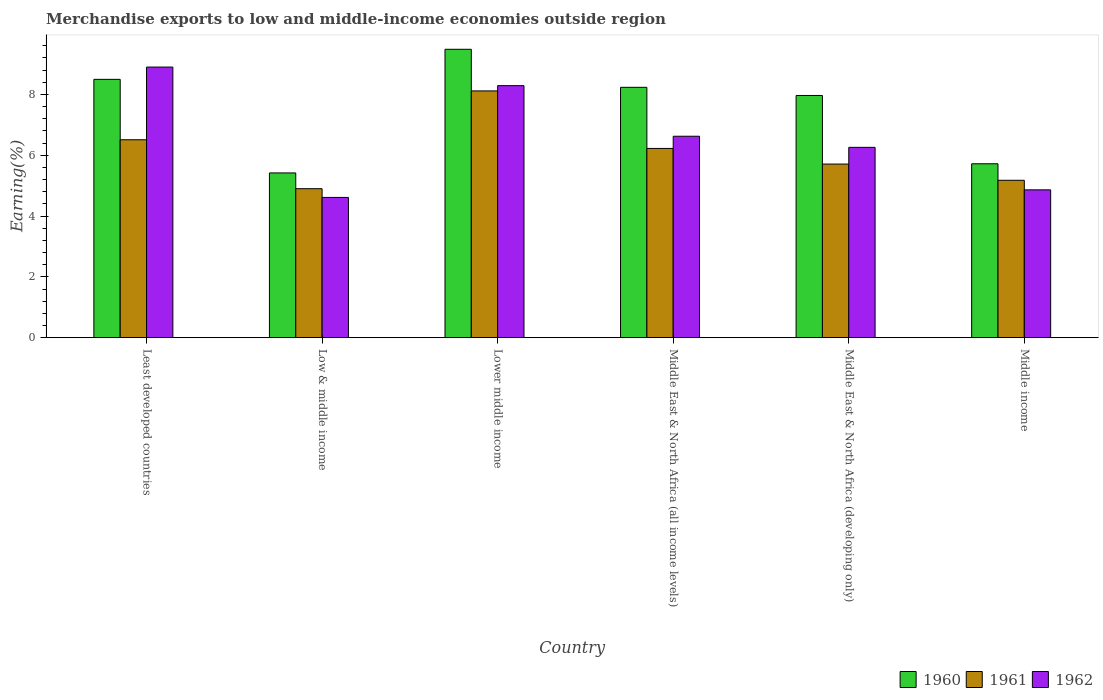What is the label of the 4th group of bars from the left?
Your answer should be very brief. Middle East & North Africa (all income levels). In how many cases, is the number of bars for a given country not equal to the number of legend labels?
Provide a short and direct response. 0. What is the percentage of amount earned from merchandise exports in 1962 in Middle East & North Africa (developing only)?
Provide a short and direct response. 6.26. Across all countries, what is the maximum percentage of amount earned from merchandise exports in 1962?
Keep it short and to the point. 8.9. Across all countries, what is the minimum percentage of amount earned from merchandise exports in 1961?
Your answer should be very brief. 4.9. In which country was the percentage of amount earned from merchandise exports in 1961 maximum?
Make the answer very short. Lower middle income. What is the total percentage of amount earned from merchandise exports in 1962 in the graph?
Give a very brief answer. 39.54. What is the difference between the percentage of amount earned from merchandise exports in 1962 in Middle East & North Africa (all income levels) and that in Middle income?
Your response must be concise. 1.76. What is the difference between the percentage of amount earned from merchandise exports in 1962 in Middle East & North Africa (all income levels) and the percentage of amount earned from merchandise exports in 1960 in Middle East & North Africa (developing only)?
Ensure brevity in your answer.  -1.34. What is the average percentage of amount earned from merchandise exports in 1961 per country?
Give a very brief answer. 6.1. What is the difference between the percentage of amount earned from merchandise exports of/in 1960 and percentage of amount earned from merchandise exports of/in 1962 in Middle income?
Provide a short and direct response. 0.86. What is the ratio of the percentage of amount earned from merchandise exports in 1960 in Least developed countries to that in Low & middle income?
Ensure brevity in your answer.  1.57. Is the difference between the percentage of amount earned from merchandise exports in 1960 in Low & middle income and Middle income greater than the difference between the percentage of amount earned from merchandise exports in 1962 in Low & middle income and Middle income?
Ensure brevity in your answer.  No. What is the difference between the highest and the second highest percentage of amount earned from merchandise exports in 1962?
Your answer should be very brief. 0.61. What is the difference between the highest and the lowest percentage of amount earned from merchandise exports in 1961?
Your response must be concise. 3.22. Is it the case that in every country, the sum of the percentage of amount earned from merchandise exports in 1962 and percentage of amount earned from merchandise exports in 1961 is greater than the percentage of amount earned from merchandise exports in 1960?
Offer a very short reply. Yes. How many countries are there in the graph?
Your response must be concise. 6. Are the values on the major ticks of Y-axis written in scientific E-notation?
Ensure brevity in your answer.  No. Does the graph contain grids?
Provide a succinct answer. No. How many legend labels are there?
Provide a succinct answer. 3. What is the title of the graph?
Offer a very short reply. Merchandise exports to low and middle-income economies outside region. Does "1966" appear as one of the legend labels in the graph?
Keep it short and to the point. No. What is the label or title of the Y-axis?
Offer a very short reply. Earning(%). What is the Earning(%) of 1960 in Least developed countries?
Your response must be concise. 8.49. What is the Earning(%) of 1961 in Least developed countries?
Make the answer very short. 6.51. What is the Earning(%) in 1962 in Least developed countries?
Your response must be concise. 8.9. What is the Earning(%) of 1960 in Low & middle income?
Offer a very short reply. 5.42. What is the Earning(%) in 1961 in Low & middle income?
Your response must be concise. 4.9. What is the Earning(%) in 1962 in Low & middle income?
Make the answer very short. 4.61. What is the Earning(%) of 1960 in Lower middle income?
Offer a terse response. 9.48. What is the Earning(%) of 1961 in Lower middle income?
Give a very brief answer. 8.11. What is the Earning(%) in 1962 in Lower middle income?
Ensure brevity in your answer.  8.29. What is the Earning(%) of 1960 in Middle East & North Africa (all income levels)?
Your answer should be very brief. 8.23. What is the Earning(%) of 1961 in Middle East & North Africa (all income levels)?
Offer a terse response. 6.22. What is the Earning(%) of 1962 in Middle East & North Africa (all income levels)?
Offer a terse response. 6.62. What is the Earning(%) in 1960 in Middle East & North Africa (developing only)?
Your response must be concise. 7.96. What is the Earning(%) of 1961 in Middle East & North Africa (developing only)?
Give a very brief answer. 5.71. What is the Earning(%) in 1962 in Middle East & North Africa (developing only)?
Make the answer very short. 6.26. What is the Earning(%) of 1960 in Middle income?
Provide a succinct answer. 5.72. What is the Earning(%) of 1961 in Middle income?
Your answer should be compact. 5.17. What is the Earning(%) of 1962 in Middle income?
Provide a short and direct response. 4.86. Across all countries, what is the maximum Earning(%) of 1960?
Provide a short and direct response. 9.48. Across all countries, what is the maximum Earning(%) of 1961?
Ensure brevity in your answer.  8.11. Across all countries, what is the maximum Earning(%) in 1962?
Keep it short and to the point. 8.9. Across all countries, what is the minimum Earning(%) in 1960?
Your response must be concise. 5.42. Across all countries, what is the minimum Earning(%) in 1961?
Keep it short and to the point. 4.9. Across all countries, what is the minimum Earning(%) of 1962?
Offer a terse response. 4.61. What is the total Earning(%) of 1960 in the graph?
Your response must be concise. 45.31. What is the total Earning(%) in 1961 in the graph?
Provide a short and direct response. 36.62. What is the total Earning(%) in 1962 in the graph?
Provide a succinct answer. 39.54. What is the difference between the Earning(%) in 1960 in Least developed countries and that in Low & middle income?
Your answer should be very brief. 3.08. What is the difference between the Earning(%) of 1961 in Least developed countries and that in Low & middle income?
Provide a succinct answer. 1.61. What is the difference between the Earning(%) in 1962 in Least developed countries and that in Low & middle income?
Your answer should be compact. 4.29. What is the difference between the Earning(%) in 1960 in Least developed countries and that in Lower middle income?
Your answer should be compact. -0.99. What is the difference between the Earning(%) in 1961 in Least developed countries and that in Lower middle income?
Offer a terse response. -1.61. What is the difference between the Earning(%) of 1962 in Least developed countries and that in Lower middle income?
Give a very brief answer. 0.61. What is the difference between the Earning(%) of 1960 in Least developed countries and that in Middle East & North Africa (all income levels)?
Provide a succinct answer. 0.26. What is the difference between the Earning(%) in 1961 in Least developed countries and that in Middle East & North Africa (all income levels)?
Provide a short and direct response. 0.29. What is the difference between the Earning(%) in 1962 in Least developed countries and that in Middle East & North Africa (all income levels)?
Keep it short and to the point. 2.27. What is the difference between the Earning(%) of 1960 in Least developed countries and that in Middle East & North Africa (developing only)?
Offer a very short reply. 0.53. What is the difference between the Earning(%) in 1961 in Least developed countries and that in Middle East & North Africa (developing only)?
Ensure brevity in your answer.  0.8. What is the difference between the Earning(%) of 1962 in Least developed countries and that in Middle East & North Africa (developing only)?
Make the answer very short. 2.64. What is the difference between the Earning(%) in 1960 in Least developed countries and that in Middle income?
Offer a terse response. 2.78. What is the difference between the Earning(%) of 1961 in Least developed countries and that in Middle income?
Provide a succinct answer. 1.33. What is the difference between the Earning(%) in 1962 in Least developed countries and that in Middle income?
Keep it short and to the point. 4.04. What is the difference between the Earning(%) of 1960 in Low & middle income and that in Lower middle income?
Provide a succinct answer. -4.07. What is the difference between the Earning(%) in 1961 in Low & middle income and that in Lower middle income?
Make the answer very short. -3.22. What is the difference between the Earning(%) in 1962 in Low & middle income and that in Lower middle income?
Provide a succinct answer. -3.68. What is the difference between the Earning(%) in 1960 in Low & middle income and that in Middle East & North Africa (all income levels)?
Offer a very short reply. -2.81. What is the difference between the Earning(%) of 1961 in Low & middle income and that in Middle East & North Africa (all income levels)?
Your response must be concise. -1.32. What is the difference between the Earning(%) of 1962 in Low & middle income and that in Middle East & North Africa (all income levels)?
Your answer should be very brief. -2.01. What is the difference between the Earning(%) of 1960 in Low & middle income and that in Middle East & North Africa (developing only)?
Provide a short and direct response. -2.55. What is the difference between the Earning(%) of 1961 in Low & middle income and that in Middle East & North Africa (developing only)?
Your answer should be very brief. -0.81. What is the difference between the Earning(%) of 1962 in Low & middle income and that in Middle East & North Africa (developing only)?
Keep it short and to the point. -1.65. What is the difference between the Earning(%) of 1960 in Low & middle income and that in Middle income?
Make the answer very short. -0.3. What is the difference between the Earning(%) in 1961 in Low & middle income and that in Middle income?
Provide a short and direct response. -0.28. What is the difference between the Earning(%) of 1962 in Low & middle income and that in Middle income?
Keep it short and to the point. -0.25. What is the difference between the Earning(%) in 1960 in Lower middle income and that in Middle East & North Africa (all income levels)?
Ensure brevity in your answer.  1.25. What is the difference between the Earning(%) in 1961 in Lower middle income and that in Middle East & North Africa (all income levels)?
Ensure brevity in your answer.  1.89. What is the difference between the Earning(%) in 1962 in Lower middle income and that in Middle East & North Africa (all income levels)?
Make the answer very short. 1.66. What is the difference between the Earning(%) of 1960 in Lower middle income and that in Middle East & North Africa (developing only)?
Offer a terse response. 1.52. What is the difference between the Earning(%) in 1961 in Lower middle income and that in Middle East & North Africa (developing only)?
Keep it short and to the point. 2.41. What is the difference between the Earning(%) in 1962 in Lower middle income and that in Middle East & North Africa (developing only)?
Your answer should be very brief. 2.03. What is the difference between the Earning(%) in 1960 in Lower middle income and that in Middle income?
Your answer should be very brief. 3.76. What is the difference between the Earning(%) of 1961 in Lower middle income and that in Middle income?
Provide a short and direct response. 2.94. What is the difference between the Earning(%) in 1962 in Lower middle income and that in Middle income?
Ensure brevity in your answer.  3.43. What is the difference between the Earning(%) in 1960 in Middle East & North Africa (all income levels) and that in Middle East & North Africa (developing only)?
Keep it short and to the point. 0.27. What is the difference between the Earning(%) of 1961 in Middle East & North Africa (all income levels) and that in Middle East & North Africa (developing only)?
Give a very brief answer. 0.51. What is the difference between the Earning(%) in 1962 in Middle East & North Africa (all income levels) and that in Middle East & North Africa (developing only)?
Your response must be concise. 0.37. What is the difference between the Earning(%) of 1960 in Middle East & North Africa (all income levels) and that in Middle income?
Ensure brevity in your answer.  2.51. What is the difference between the Earning(%) of 1961 in Middle East & North Africa (all income levels) and that in Middle income?
Provide a succinct answer. 1.05. What is the difference between the Earning(%) of 1962 in Middle East & North Africa (all income levels) and that in Middle income?
Give a very brief answer. 1.76. What is the difference between the Earning(%) of 1960 in Middle East & North Africa (developing only) and that in Middle income?
Your answer should be compact. 2.25. What is the difference between the Earning(%) in 1961 in Middle East & North Africa (developing only) and that in Middle income?
Offer a very short reply. 0.53. What is the difference between the Earning(%) of 1962 in Middle East & North Africa (developing only) and that in Middle income?
Provide a short and direct response. 1.4. What is the difference between the Earning(%) in 1960 in Least developed countries and the Earning(%) in 1961 in Low & middle income?
Give a very brief answer. 3.6. What is the difference between the Earning(%) of 1960 in Least developed countries and the Earning(%) of 1962 in Low & middle income?
Provide a succinct answer. 3.88. What is the difference between the Earning(%) in 1961 in Least developed countries and the Earning(%) in 1962 in Low & middle income?
Make the answer very short. 1.9. What is the difference between the Earning(%) in 1960 in Least developed countries and the Earning(%) in 1961 in Lower middle income?
Provide a succinct answer. 0.38. What is the difference between the Earning(%) of 1960 in Least developed countries and the Earning(%) of 1962 in Lower middle income?
Give a very brief answer. 0.21. What is the difference between the Earning(%) of 1961 in Least developed countries and the Earning(%) of 1962 in Lower middle income?
Give a very brief answer. -1.78. What is the difference between the Earning(%) of 1960 in Least developed countries and the Earning(%) of 1961 in Middle East & North Africa (all income levels)?
Offer a terse response. 2.27. What is the difference between the Earning(%) of 1960 in Least developed countries and the Earning(%) of 1962 in Middle East & North Africa (all income levels)?
Your response must be concise. 1.87. What is the difference between the Earning(%) in 1961 in Least developed countries and the Earning(%) in 1962 in Middle East & North Africa (all income levels)?
Give a very brief answer. -0.12. What is the difference between the Earning(%) of 1960 in Least developed countries and the Earning(%) of 1961 in Middle East & North Africa (developing only)?
Your response must be concise. 2.79. What is the difference between the Earning(%) in 1960 in Least developed countries and the Earning(%) in 1962 in Middle East & North Africa (developing only)?
Your answer should be compact. 2.24. What is the difference between the Earning(%) in 1961 in Least developed countries and the Earning(%) in 1962 in Middle East & North Africa (developing only)?
Keep it short and to the point. 0.25. What is the difference between the Earning(%) in 1960 in Least developed countries and the Earning(%) in 1961 in Middle income?
Your answer should be compact. 3.32. What is the difference between the Earning(%) of 1960 in Least developed countries and the Earning(%) of 1962 in Middle income?
Offer a terse response. 3.63. What is the difference between the Earning(%) in 1961 in Least developed countries and the Earning(%) in 1962 in Middle income?
Make the answer very short. 1.65. What is the difference between the Earning(%) in 1960 in Low & middle income and the Earning(%) in 1961 in Lower middle income?
Offer a very short reply. -2.7. What is the difference between the Earning(%) of 1960 in Low & middle income and the Earning(%) of 1962 in Lower middle income?
Your answer should be compact. -2.87. What is the difference between the Earning(%) of 1961 in Low & middle income and the Earning(%) of 1962 in Lower middle income?
Offer a terse response. -3.39. What is the difference between the Earning(%) of 1960 in Low & middle income and the Earning(%) of 1961 in Middle East & North Africa (all income levels)?
Offer a very short reply. -0.81. What is the difference between the Earning(%) in 1960 in Low & middle income and the Earning(%) in 1962 in Middle East & North Africa (all income levels)?
Offer a very short reply. -1.21. What is the difference between the Earning(%) in 1961 in Low & middle income and the Earning(%) in 1962 in Middle East & North Africa (all income levels)?
Give a very brief answer. -1.72. What is the difference between the Earning(%) in 1960 in Low & middle income and the Earning(%) in 1961 in Middle East & North Africa (developing only)?
Make the answer very short. -0.29. What is the difference between the Earning(%) in 1960 in Low & middle income and the Earning(%) in 1962 in Middle East & North Africa (developing only)?
Keep it short and to the point. -0.84. What is the difference between the Earning(%) of 1961 in Low & middle income and the Earning(%) of 1962 in Middle East & North Africa (developing only)?
Your response must be concise. -1.36. What is the difference between the Earning(%) in 1960 in Low & middle income and the Earning(%) in 1961 in Middle income?
Offer a terse response. 0.24. What is the difference between the Earning(%) of 1960 in Low & middle income and the Earning(%) of 1962 in Middle income?
Make the answer very short. 0.56. What is the difference between the Earning(%) of 1961 in Low & middle income and the Earning(%) of 1962 in Middle income?
Provide a succinct answer. 0.04. What is the difference between the Earning(%) of 1960 in Lower middle income and the Earning(%) of 1961 in Middle East & North Africa (all income levels)?
Offer a very short reply. 3.26. What is the difference between the Earning(%) of 1960 in Lower middle income and the Earning(%) of 1962 in Middle East & North Africa (all income levels)?
Ensure brevity in your answer.  2.86. What is the difference between the Earning(%) of 1961 in Lower middle income and the Earning(%) of 1962 in Middle East & North Africa (all income levels)?
Your response must be concise. 1.49. What is the difference between the Earning(%) of 1960 in Lower middle income and the Earning(%) of 1961 in Middle East & North Africa (developing only)?
Offer a very short reply. 3.77. What is the difference between the Earning(%) in 1960 in Lower middle income and the Earning(%) in 1962 in Middle East & North Africa (developing only)?
Your answer should be very brief. 3.22. What is the difference between the Earning(%) in 1961 in Lower middle income and the Earning(%) in 1962 in Middle East & North Africa (developing only)?
Ensure brevity in your answer.  1.86. What is the difference between the Earning(%) in 1960 in Lower middle income and the Earning(%) in 1961 in Middle income?
Keep it short and to the point. 4.31. What is the difference between the Earning(%) in 1960 in Lower middle income and the Earning(%) in 1962 in Middle income?
Ensure brevity in your answer.  4.62. What is the difference between the Earning(%) of 1961 in Lower middle income and the Earning(%) of 1962 in Middle income?
Give a very brief answer. 3.25. What is the difference between the Earning(%) of 1960 in Middle East & North Africa (all income levels) and the Earning(%) of 1961 in Middle East & North Africa (developing only)?
Keep it short and to the point. 2.52. What is the difference between the Earning(%) of 1960 in Middle East & North Africa (all income levels) and the Earning(%) of 1962 in Middle East & North Africa (developing only)?
Your answer should be very brief. 1.97. What is the difference between the Earning(%) in 1961 in Middle East & North Africa (all income levels) and the Earning(%) in 1962 in Middle East & North Africa (developing only)?
Your answer should be very brief. -0.04. What is the difference between the Earning(%) of 1960 in Middle East & North Africa (all income levels) and the Earning(%) of 1961 in Middle income?
Provide a short and direct response. 3.06. What is the difference between the Earning(%) in 1960 in Middle East & North Africa (all income levels) and the Earning(%) in 1962 in Middle income?
Offer a very short reply. 3.37. What is the difference between the Earning(%) of 1961 in Middle East & North Africa (all income levels) and the Earning(%) of 1962 in Middle income?
Make the answer very short. 1.36. What is the difference between the Earning(%) of 1960 in Middle East & North Africa (developing only) and the Earning(%) of 1961 in Middle income?
Ensure brevity in your answer.  2.79. What is the difference between the Earning(%) of 1960 in Middle East & North Africa (developing only) and the Earning(%) of 1962 in Middle income?
Keep it short and to the point. 3.1. What is the difference between the Earning(%) in 1961 in Middle East & North Africa (developing only) and the Earning(%) in 1962 in Middle income?
Offer a terse response. 0.85. What is the average Earning(%) in 1960 per country?
Keep it short and to the point. 7.55. What is the average Earning(%) of 1961 per country?
Your answer should be very brief. 6.1. What is the average Earning(%) in 1962 per country?
Keep it short and to the point. 6.59. What is the difference between the Earning(%) of 1960 and Earning(%) of 1961 in Least developed countries?
Your response must be concise. 1.99. What is the difference between the Earning(%) in 1960 and Earning(%) in 1962 in Least developed countries?
Ensure brevity in your answer.  -0.4. What is the difference between the Earning(%) in 1961 and Earning(%) in 1962 in Least developed countries?
Keep it short and to the point. -2.39. What is the difference between the Earning(%) in 1960 and Earning(%) in 1961 in Low & middle income?
Offer a very short reply. 0.52. What is the difference between the Earning(%) of 1960 and Earning(%) of 1962 in Low & middle income?
Your response must be concise. 0.81. What is the difference between the Earning(%) of 1961 and Earning(%) of 1962 in Low & middle income?
Provide a succinct answer. 0.29. What is the difference between the Earning(%) in 1960 and Earning(%) in 1961 in Lower middle income?
Provide a succinct answer. 1.37. What is the difference between the Earning(%) of 1960 and Earning(%) of 1962 in Lower middle income?
Provide a short and direct response. 1.2. What is the difference between the Earning(%) in 1961 and Earning(%) in 1962 in Lower middle income?
Your answer should be compact. -0.17. What is the difference between the Earning(%) of 1960 and Earning(%) of 1961 in Middle East & North Africa (all income levels)?
Ensure brevity in your answer.  2.01. What is the difference between the Earning(%) of 1960 and Earning(%) of 1962 in Middle East & North Africa (all income levels)?
Ensure brevity in your answer.  1.61. What is the difference between the Earning(%) of 1961 and Earning(%) of 1962 in Middle East & North Africa (all income levels)?
Ensure brevity in your answer.  -0.4. What is the difference between the Earning(%) of 1960 and Earning(%) of 1961 in Middle East & North Africa (developing only)?
Your answer should be compact. 2.26. What is the difference between the Earning(%) of 1960 and Earning(%) of 1962 in Middle East & North Africa (developing only)?
Keep it short and to the point. 1.71. What is the difference between the Earning(%) of 1961 and Earning(%) of 1962 in Middle East & North Africa (developing only)?
Offer a terse response. -0.55. What is the difference between the Earning(%) in 1960 and Earning(%) in 1961 in Middle income?
Keep it short and to the point. 0.54. What is the difference between the Earning(%) in 1960 and Earning(%) in 1962 in Middle income?
Your response must be concise. 0.86. What is the difference between the Earning(%) of 1961 and Earning(%) of 1962 in Middle income?
Provide a short and direct response. 0.31. What is the ratio of the Earning(%) in 1960 in Least developed countries to that in Low & middle income?
Offer a terse response. 1.57. What is the ratio of the Earning(%) of 1961 in Least developed countries to that in Low & middle income?
Give a very brief answer. 1.33. What is the ratio of the Earning(%) of 1962 in Least developed countries to that in Low & middle income?
Your answer should be compact. 1.93. What is the ratio of the Earning(%) in 1960 in Least developed countries to that in Lower middle income?
Provide a succinct answer. 0.9. What is the ratio of the Earning(%) of 1961 in Least developed countries to that in Lower middle income?
Ensure brevity in your answer.  0.8. What is the ratio of the Earning(%) in 1962 in Least developed countries to that in Lower middle income?
Give a very brief answer. 1.07. What is the ratio of the Earning(%) in 1960 in Least developed countries to that in Middle East & North Africa (all income levels)?
Your answer should be very brief. 1.03. What is the ratio of the Earning(%) in 1961 in Least developed countries to that in Middle East & North Africa (all income levels)?
Offer a terse response. 1.05. What is the ratio of the Earning(%) of 1962 in Least developed countries to that in Middle East & North Africa (all income levels)?
Give a very brief answer. 1.34. What is the ratio of the Earning(%) in 1960 in Least developed countries to that in Middle East & North Africa (developing only)?
Make the answer very short. 1.07. What is the ratio of the Earning(%) in 1961 in Least developed countries to that in Middle East & North Africa (developing only)?
Provide a succinct answer. 1.14. What is the ratio of the Earning(%) in 1962 in Least developed countries to that in Middle East & North Africa (developing only)?
Ensure brevity in your answer.  1.42. What is the ratio of the Earning(%) in 1960 in Least developed countries to that in Middle income?
Keep it short and to the point. 1.49. What is the ratio of the Earning(%) in 1961 in Least developed countries to that in Middle income?
Offer a terse response. 1.26. What is the ratio of the Earning(%) of 1962 in Least developed countries to that in Middle income?
Keep it short and to the point. 1.83. What is the ratio of the Earning(%) in 1960 in Low & middle income to that in Lower middle income?
Offer a terse response. 0.57. What is the ratio of the Earning(%) of 1961 in Low & middle income to that in Lower middle income?
Offer a very short reply. 0.6. What is the ratio of the Earning(%) in 1962 in Low & middle income to that in Lower middle income?
Your response must be concise. 0.56. What is the ratio of the Earning(%) of 1960 in Low & middle income to that in Middle East & North Africa (all income levels)?
Offer a very short reply. 0.66. What is the ratio of the Earning(%) of 1961 in Low & middle income to that in Middle East & North Africa (all income levels)?
Offer a very short reply. 0.79. What is the ratio of the Earning(%) of 1962 in Low & middle income to that in Middle East & North Africa (all income levels)?
Offer a very short reply. 0.7. What is the ratio of the Earning(%) of 1960 in Low & middle income to that in Middle East & North Africa (developing only)?
Give a very brief answer. 0.68. What is the ratio of the Earning(%) of 1961 in Low & middle income to that in Middle East & North Africa (developing only)?
Your answer should be compact. 0.86. What is the ratio of the Earning(%) of 1962 in Low & middle income to that in Middle East & North Africa (developing only)?
Provide a short and direct response. 0.74. What is the ratio of the Earning(%) in 1960 in Low & middle income to that in Middle income?
Ensure brevity in your answer.  0.95. What is the ratio of the Earning(%) in 1961 in Low & middle income to that in Middle income?
Offer a terse response. 0.95. What is the ratio of the Earning(%) of 1962 in Low & middle income to that in Middle income?
Your answer should be compact. 0.95. What is the ratio of the Earning(%) of 1960 in Lower middle income to that in Middle East & North Africa (all income levels)?
Give a very brief answer. 1.15. What is the ratio of the Earning(%) in 1961 in Lower middle income to that in Middle East & North Africa (all income levels)?
Your response must be concise. 1.3. What is the ratio of the Earning(%) in 1962 in Lower middle income to that in Middle East & North Africa (all income levels)?
Keep it short and to the point. 1.25. What is the ratio of the Earning(%) of 1960 in Lower middle income to that in Middle East & North Africa (developing only)?
Offer a terse response. 1.19. What is the ratio of the Earning(%) in 1961 in Lower middle income to that in Middle East & North Africa (developing only)?
Offer a terse response. 1.42. What is the ratio of the Earning(%) of 1962 in Lower middle income to that in Middle East & North Africa (developing only)?
Offer a very short reply. 1.32. What is the ratio of the Earning(%) in 1960 in Lower middle income to that in Middle income?
Make the answer very short. 1.66. What is the ratio of the Earning(%) of 1961 in Lower middle income to that in Middle income?
Provide a short and direct response. 1.57. What is the ratio of the Earning(%) in 1962 in Lower middle income to that in Middle income?
Your answer should be very brief. 1.71. What is the ratio of the Earning(%) in 1960 in Middle East & North Africa (all income levels) to that in Middle East & North Africa (developing only)?
Offer a terse response. 1.03. What is the ratio of the Earning(%) of 1961 in Middle East & North Africa (all income levels) to that in Middle East & North Africa (developing only)?
Offer a terse response. 1.09. What is the ratio of the Earning(%) of 1962 in Middle East & North Africa (all income levels) to that in Middle East & North Africa (developing only)?
Ensure brevity in your answer.  1.06. What is the ratio of the Earning(%) of 1960 in Middle East & North Africa (all income levels) to that in Middle income?
Provide a succinct answer. 1.44. What is the ratio of the Earning(%) in 1961 in Middle East & North Africa (all income levels) to that in Middle income?
Your response must be concise. 1.2. What is the ratio of the Earning(%) in 1962 in Middle East & North Africa (all income levels) to that in Middle income?
Offer a terse response. 1.36. What is the ratio of the Earning(%) in 1960 in Middle East & North Africa (developing only) to that in Middle income?
Provide a succinct answer. 1.39. What is the ratio of the Earning(%) in 1961 in Middle East & North Africa (developing only) to that in Middle income?
Ensure brevity in your answer.  1.1. What is the ratio of the Earning(%) of 1962 in Middle East & North Africa (developing only) to that in Middle income?
Your answer should be very brief. 1.29. What is the difference between the highest and the second highest Earning(%) in 1960?
Ensure brevity in your answer.  0.99. What is the difference between the highest and the second highest Earning(%) in 1961?
Provide a succinct answer. 1.61. What is the difference between the highest and the second highest Earning(%) in 1962?
Give a very brief answer. 0.61. What is the difference between the highest and the lowest Earning(%) in 1960?
Provide a short and direct response. 4.07. What is the difference between the highest and the lowest Earning(%) of 1961?
Give a very brief answer. 3.22. What is the difference between the highest and the lowest Earning(%) in 1962?
Offer a terse response. 4.29. 